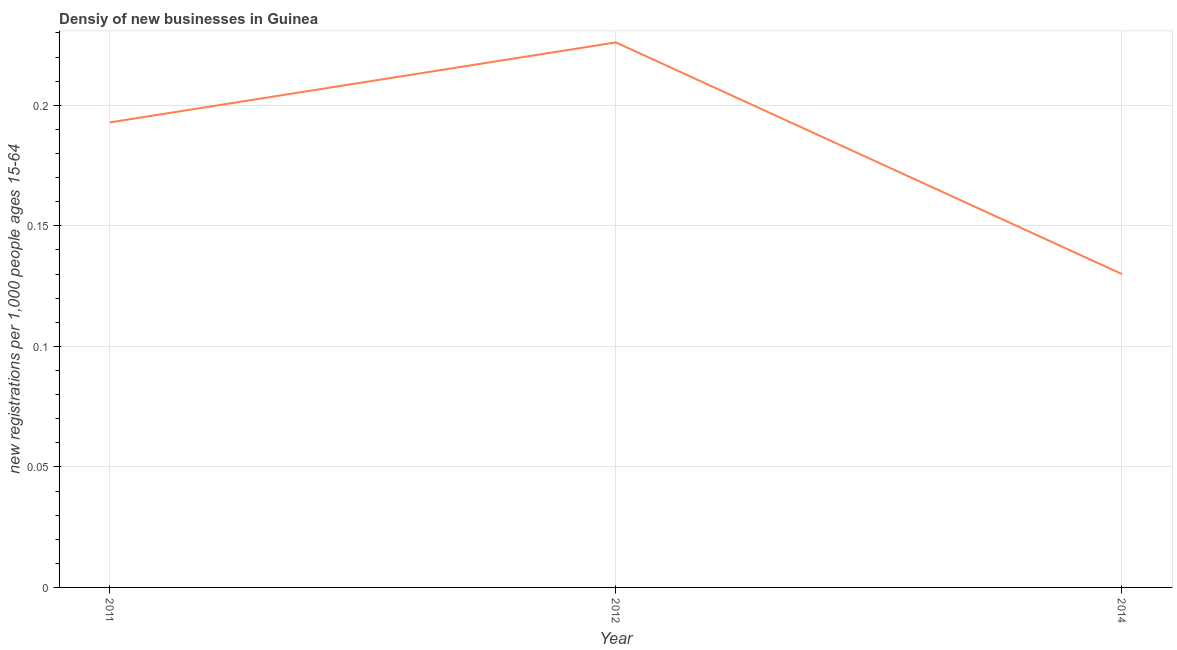What is the density of new business in 2012?
Offer a very short reply. 0.23. Across all years, what is the maximum density of new business?
Your answer should be very brief. 0.23. Across all years, what is the minimum density of new business?
Provide a succinct answer. 0.13. In which year was the density of new business maximum?
Give a very brief answer. 2012. In which year was the density of new business minimum?
Your response must be concise. 2014. What is the sum of the density of new business?
Give a very brief answer. 0.55. What is the difference between the density of new business in 2011 and 2012?
Offer a terse response. -0.03. What is the average density of new business per year?
Make the answer very short. 0.18. What is the median density of new business?
Offer a terse response. 0.19. Do a majority of the years between 2011 and 2014 (inclusive) have density of new business greater than 0.16000000000000003 ?
Your response must be concise. Yes. What is the ratio of the density of new business in 2012 to that in 2014?
Make the answer very short. 1.74. Is the difference between the density of new business in 2011 and 2014 greater than the difference between any two years?
Your answer should be compact. No. What is the difference between the highest and the second highest density of new business?
Give a very brief answer. 0.03. Is the sum of the density of new business in 2011 and 2012 greater than the maximum density of new business across all years?
Your response must be concise. Yes. What is the difference between the highest and the lowest density of new business?
Offer a terse response. 0.1. In how many years, is the density of new business greater than the average density of new business taken over all years?
Provide a short and direct response. 2. Does the density of new business monotonically increase over the years?
Give a very brief answer. No. How many lines are there?
Your answer should be compact. 1. What is the difference between two consecutive major ticks on the Y-axis?
Offer a terse response. 0.05. Are the values on the major ticks of Y-axis written in scientific E-notation?
Offer a terse response. No. What is the title of the graph?
Give a very brief answer. Densiy of new businesses in Guinea. What is the label or title of the X-axis?
Provide a succinct answer. Year. What is the label or title of the Y-axis?
Offer a very short reply. New registrations per 1,0 people ages 15-64. What is the new registrations per 1,000 people ages 15-64 in 2011?
Offer a terse response. 0.19. What is the new registrations per 1,000 people ages 15-64 in 2012?
Provide a succinct answer. 0.23. What is the new registrations per 1,000 people ages 15-64 in 2014?
Make the answer very short. 0.13. What is the difference between the new registrations per 1,000 people ages 15-64 in 2011 and 2012?
Provide a short and direct response. -0.03. What is the difference between the new registrations per 1,000 people ages 15-64 in 2011 and 2014?
Your response must be concise. 0.06. What is the difference between the new registrations per 1,000 people ages 15-64 in 2012 and 2014?
Provide a succinct answer. 0.1. What is the ratio of the new registrations per 1,000 people ages 15-64 in 2011 to that in 2012?
Keep it short and to the point. 0.85. What is the ratio of the new registrations per 1,000 people ages 15-64 in 2011 to that in 2014?
Make the answer very short. 1.48. What is the ratio of the new registrations per 1,000 people ages 15-64 in 2012 to that in 2014?
Your answer should be compact. 1.74. 